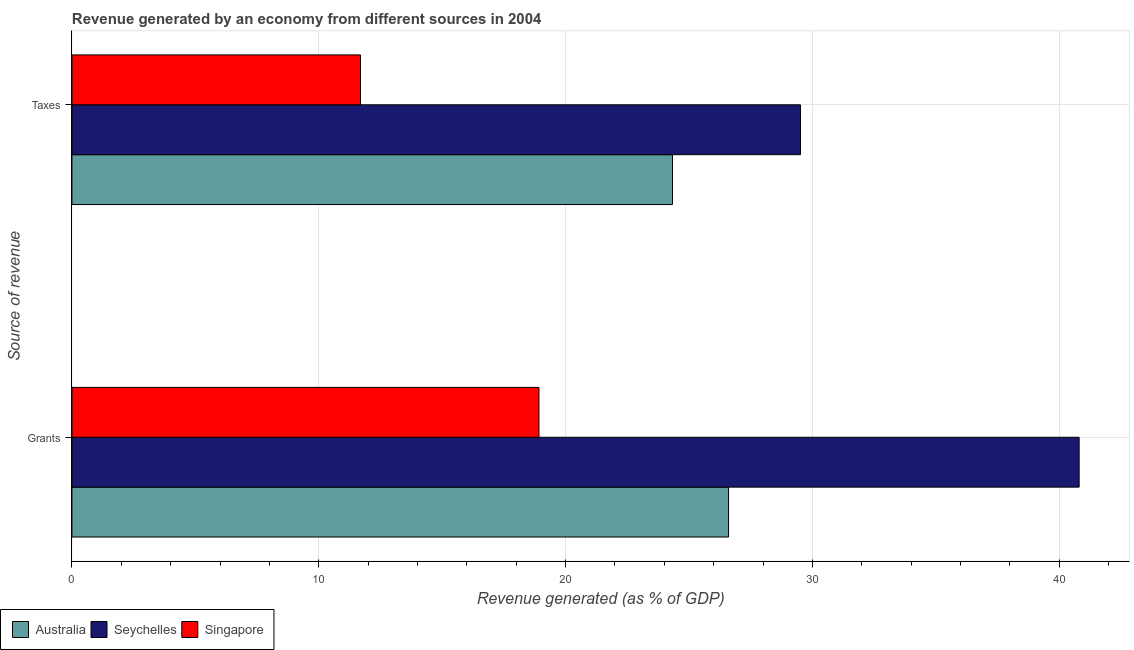How many different coloured bars are there?
Offer a terse response. 3. Are the number of bars on each tick of the Y-axis equal?
Your response must be concise. Yes. How many bars are there on the 2nd tick from the bottom?
Provide a short and direct response. 3. What is the label of the 1st group of bars from the top?
Offer a very short reply. Taxes. What is the revenue generated by taxes in Seychelles?
Your response must be concise. 29.52. Across all countries, what is the maximum revenue generated by taxes?
Offer a terse response. 29.52. Across all countries, what is the minimum revenue generated by grants?
Give a very brief answer. 18.92. In which country was the revenue generated by grants maximum?
Offer a very short reply. Seychelles. In which country was the revenue generated by taxes minimum?
Ensure brevity in your answer.  Singapore. What is the total revenue generated by taxes in the graph?
Give a very brief answer. 65.54. What is the difference between the revenue generated by grants in Seychelles and that in Singapore?
Offer a very short reply. 21.88. What is the difference between the revenue generated by grants in Australia and the revenue generated by taxes in Seychelles?
Your response must be concise. -2.91. What is the average revenue generated by grants per country?
Your response must be concise. 28.78. What is the difference between the revenue generated by grants and revenue generated by taxes in Seychelles?
Your answer should be compact. 11.29. In how many countries, is the revenue generated by grants greater than 26 %?
Offer a terse response. 2. What is the ratio of the revenue generated by taxes in Australia to that in Singapore?
Your answer should be compact. 2.08. Is the revenue generated by taxes in Singapore less than that in Australia?
Keep it short and to the point. Yes. What does the 1st bar from the bottom in Grants represents?
Keep it short and to the point. Australia. How many bars are there?
Give a very brief answer. 6. Are all the bars in the graph horizontal?
Make the answer very short. Yes. How many countries are there in the graph?
Offer a terse response. 3. Does the graph contain grids?
Give a very brief answer. Yes. How many legend labels are there?
Provide a succinct answer. 3. What is the title of the graph?
Provide a succinct answer. Revenue generated by an economy from different sources in 2004. What is the label or title of the X-axis?
Provide a short and direct response. Revenue generated (as % of GDP). What is the label or title of the Y-axis?
Ensure brevity in your answer.  Source of revenue. What is the Revenue generated (as % of GDP) of Australia in Grants?
Keep it short and to the point. 26.6. What is the Revenue generated (as % of GDP) in Seychelles in Grants?
Your answer should be very brief. 40.81. What is the Revenue generated (as % of GDP) of Singapore in Grants?
Give a very brief answer. 18.92. What is the Revenue generated (as % of GDP) of Australia in Taxes?
Offer a very short reply. 24.33. What is the Revenue generated (as % of GDP) in Seychelles in Taxes?
Give a very brief answer. 29.52. What is the Revenue generated (as % of GDP) in Singapore in Taxes?
Provide a succinct answer. 11.69. Across all Source of revenue, what is the maximum Revenue generated (as % of GDP) in Australia?
Give a very brief answer. 26.6. Across all Source of revenue, what is the maximum Revenue generated (as % of GDP) of Seychelles?
Provide a succinct answer. 40.81. Across all Source of revenue, what is the maximum Revenue generated (as % of GDP) of Singapore?
Provide a short and direct response. 18.92. Across all Source of revenue, what is the minimum Revenue generated (as % of GDP) of Australia?
Ensure brevity in your answer.  24.33. Across all Source of revenue, what is the minimum Revenue generated (as % of GDP) of Seychelles?
Provide a short and direct response. 29.52. Across all Source of revenue, what is the minimum Revenue generated (as % of GDP) of Singapore?
Offer a very short reply. 11.69. What is the total Revenue generated (as % of GDP) of Australia in the graph?
Your answer should be very brief. 50.93. What is the total Revenue generated (as % of GDP) of Seychelles in the graph?
Make the answer very short. 70.32. What is the total Revenue generated (as % of GDP) of Singapore in the graph?
Provide a succinct answer. 30.61. What is the difference between the Revenue generated (as % of GDP) of Australia in Grants and that in Taxes?
Your response must be concise. 2.27. What is the difference between the Revenue generated (as % of GDP) in Seychelles in Grants and that in Taxes?
Provide a short and direct response. 11.29. What is the difference between the Revenue generated (as % of GDP) of Singapore in Grants and that in Taxes?
Offer a terse response. 7.23. What is the difference between the Revenue generated (as % of GDP) of Australia in Grants and the Revenue generated (as % of GDP) of Seychelles in Taxes?
Your answer should be very brief. -2.91. What is the difference between the Revenue generated (as % of GDP) in Australia in Grants and the Revenue generated (as % of GDP) in Singapore in Taxes?
Offer a very short reply. 14.91. What is the difference between the Revenue generated (as % of GDP) of Seychelles in Grants and the Revenue generated (as % of GDP) of Singapore in Taxes?
Make the answer very short. 29.12. What is the average Revenue generated (as % of GDP) of Australia per Source of revenue?
Your answer should be compact. 25.47. What is the average Revenue generated (as % of GDP) in Seychelles per Source of revenue?
Provide a short and direct response. 35.16. What is the average Revenue generated (as % of GDP) of Singapore per Source of revenue?
Provide a succinct answer. 15.31. What is the difference between the Revenue generated (as % of GDP) of Australia and Revenue generated (as % of GDP) of Seychelles in Grants?
Your answer should be compact. -14.2. What is the difference between the Revenue generated (as % of GDP) in Australia and Revenue generated (as % of GDP) in Singapore in Grants?
Give a very brief answer. 7.68. What is the difference between the Revenue generated (as % of GDP) of Seychelles and Revenue generated (as % of GDP) of Singapore in Grants?
Your answer should be compact. 21.88. What is the difference between the Revenue generated (as % of GDP) in Australia and Revenue generated (as % of GDP) in Seychelles in Taxes?
Your answer should be compact. -5.19. What is the difference between the Revenue generated (as % of GDP) of Australia and Revenue generated (as % of GDP) of Singapore in Taxes?
Provide a short and direct response. 12.64. What is the difference between the Revenue generated (as % of GDP) of Seychelles and Revenue generated (as % of GDP) of Singapore in Taxes?
Provide a short and direct response. 17.82. What is the ratio of the Revenue generated (as % of GDP) of Australia in Grants to that in Taxes?
Offer a terse response. 1.09. What is the ratio of the Revenue generated (as % of GDP) of Seychelles in Grants to that in Taxes?
Make the answer very short. 1.38. What is the ratio of the Revenue generated (as % of GDP) in Singapore in Grants to that in Taxes?
Make the answer very short. 1.62. What is the difference between the highest and the second highest Revenue generated (as % of GDP) of Australia?
Offer a terse response. 2.27. What is the difference between the highest and the second highest Revenue generated (as % of GDP) of Seychelles?
Make the answer very short. 11.29. What is the difference between the highest and the second highest Revenue generated (as % of GDP) of Singapore?
Offer a very short reply. 7.23. What is the difference between the highest and the lowest Revenue generated (as % of GDP) in Australia?
Provide a succinct answer. 2.27. What is the difference between the highest and the lowest Revenue generated (as % of GDP) in Seychelles?
Your answer should be compact. 11.29. What is the difference between the highest and the lowest Revenue generated (as % of GDP) in Singapore?
Make the answer very short. 7.23. 